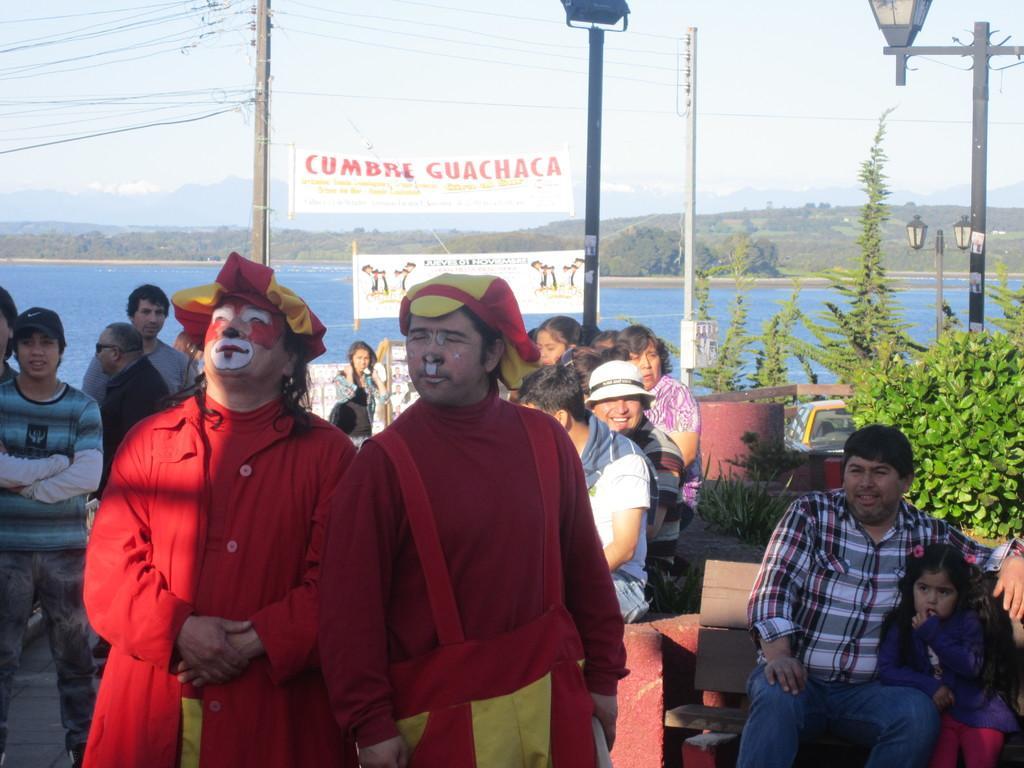Please provide a concise description of this image. There is a river and in front of the river,there are some people and in the front there are two men wearing red costume and makeup and in the right side there are many trees and lights to the poles and current wires. 